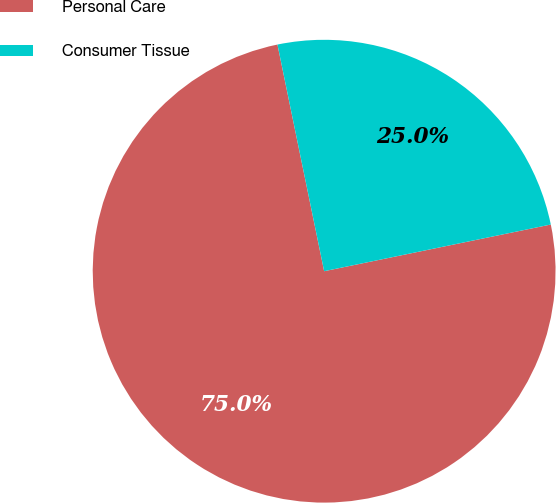Convert chart to OTSL. <chart><loc_0><loc_0><loc_500><loc_500><pie_chart><fcel>Personal Care<fcel>Consumer Tissue<nl><fcel>75.0%<fcel>25.0%<nl></chart> 